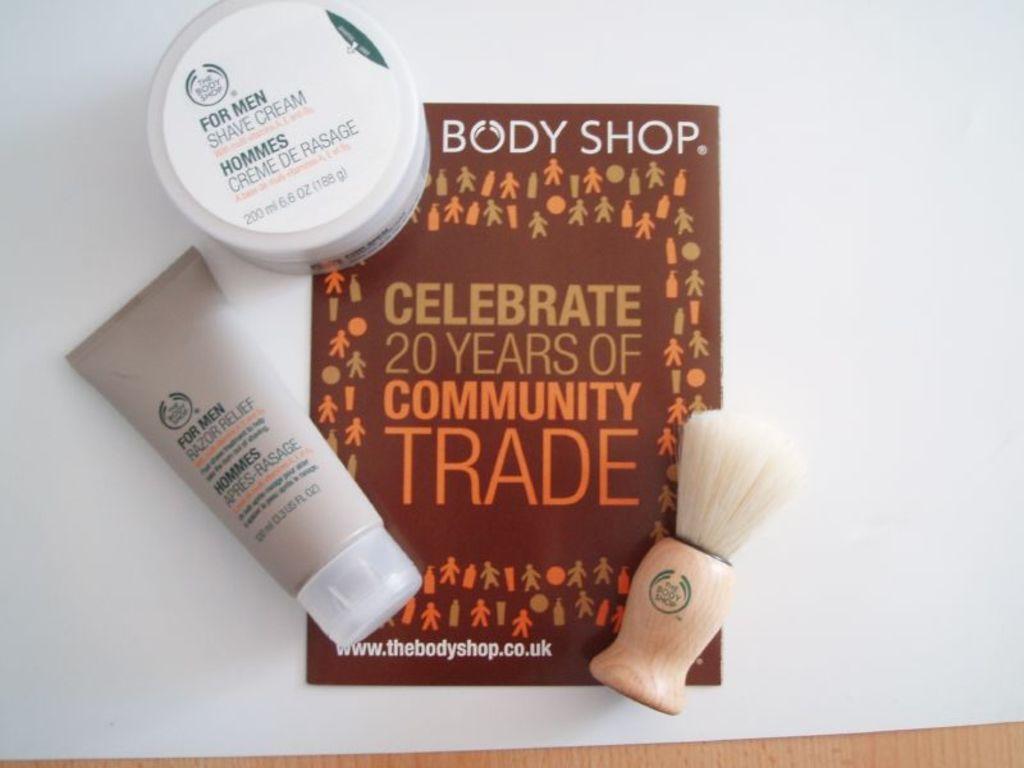What shop is this product from?
Keep it short and to the point. Body shop. How many years of community trade?
Your answer should be very brief. 20. 